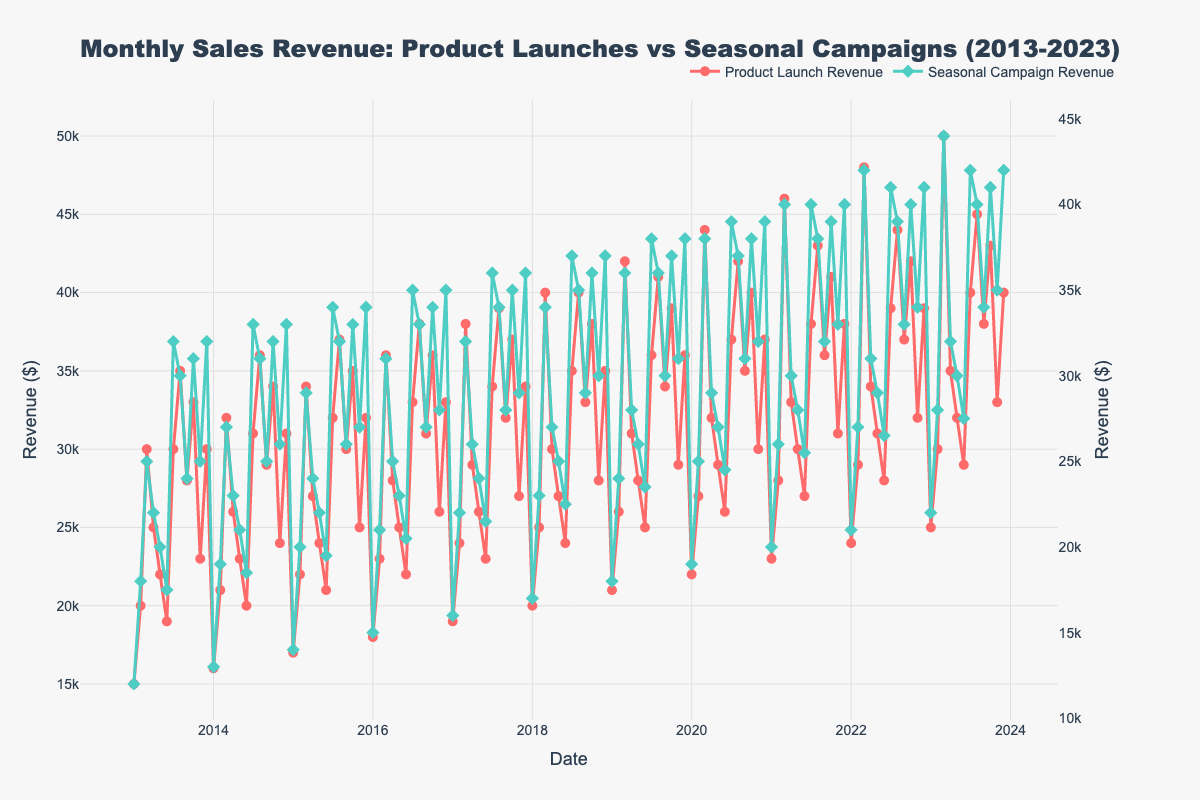What are the titles on the x and y axes? The x-axis title is "Date" and the y-axes titles are "Revenue ($)" for both primary and secondary y-axes. This is indicated by the updated layout of the axes in the plot.
Answer: Date, Revenue ($) How many times did the Product Launch Revenue reach or exceed $40,000? You need to count all the data points in the Product Launch Revenue line that hit or exceed $40,000. These points are August 2021, March 2022, August 2022, October 2022, March 2023, August 2023, and October 2023.
Answer: 7 In which month and year was the Seasonal Campaign Revenue highest? The highest point on the Seasonal Campaign Revenue line is in March 2023, which is the peak value.
Answer: March 2023 Compare the revenues in July 2020 for both Product Launches and Seasonal Campaigns. Which was higher? The value of Product Launch Revenue in July 2020 was $37,000, while the value of Seasonal Campaign Revenue was $39,000. By comparing these two values, the Seasonal Campaign Revenue was higher.
Answer: Seasonal Campaign Revenue What is the general trend of Seasonal Campaign Revenue over the years? Observing the Seasonal Campaign Revenue line across the entire time span, it generally shows an upward trend, with minor fluctuations, increasing from around $12,000 in January 2013 to around $40,000 in December 2023.
Answer: Upward trend Between which two consecutive years did Product Launch Revenue experience the steepest rise? By analyzing the Product Launch Revenue line, the steepest rise appears between 2022 and 2023, with a significant increase from around $24,000 in January 2022 to $50,000 in March 2023.
Answer: 2022 and 2023 How often does the Seasonal Campaign Revenue cross the $30,000 mark after 2017? The Seasonal Campaign Revenue crosses the $30,000 mark many times after 2017. Notably, it stays consistently above $30,000 from July 2018 onwards.
Answer: Frequently from July 2018 onward In what month and year did both Product Launch Revenue and Seasonal Campaign Revenue peak simultaneously? Both Product Launch Revenue and Seasonal Campaign Revenue peaked simultaneously in December 2023.
Answer: December 2023 What was the difference between Product Launch Revenue and Seasonal Campaign Revenue in March 2023? The Product Launch Revenue in March 2023 was $50,000 and the Seasonal Campaign Revenue was $44,000. The difference is $50,000 - $44,000 = $6,000.
Answer: $6,000 What months show a seasonal increase in both types of revenue? The months of July and December show seasonal increases in both Product Launch Revenue and Seasonal Campaign Revenue, especially notable in multiple years.
Answer: July and December 